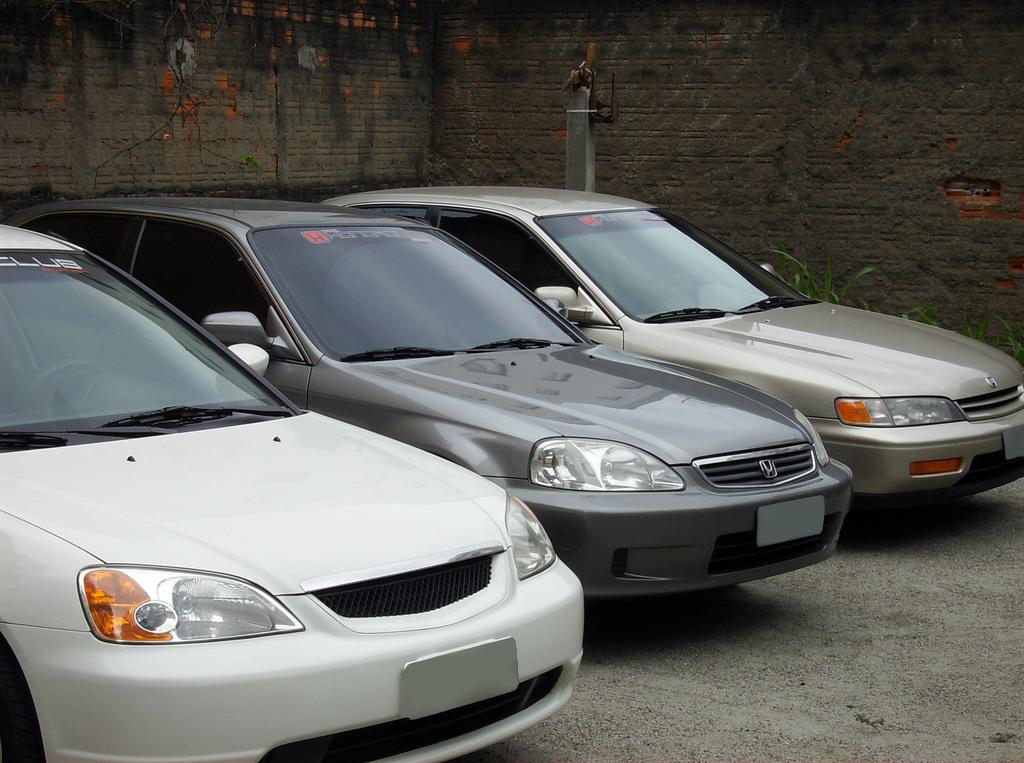What type of vehicles can be seen in the image? There are cars in the image. What is visible in the background of the image? There is a wall in the background of the image. What type of legal advice can be obtained from the cars in the image? There are no lawyers or legal advice present in the image; it features cars and a wall. What type of seating is available in the image? There is no cushion or seating present in the image; it features cars and a wall. 